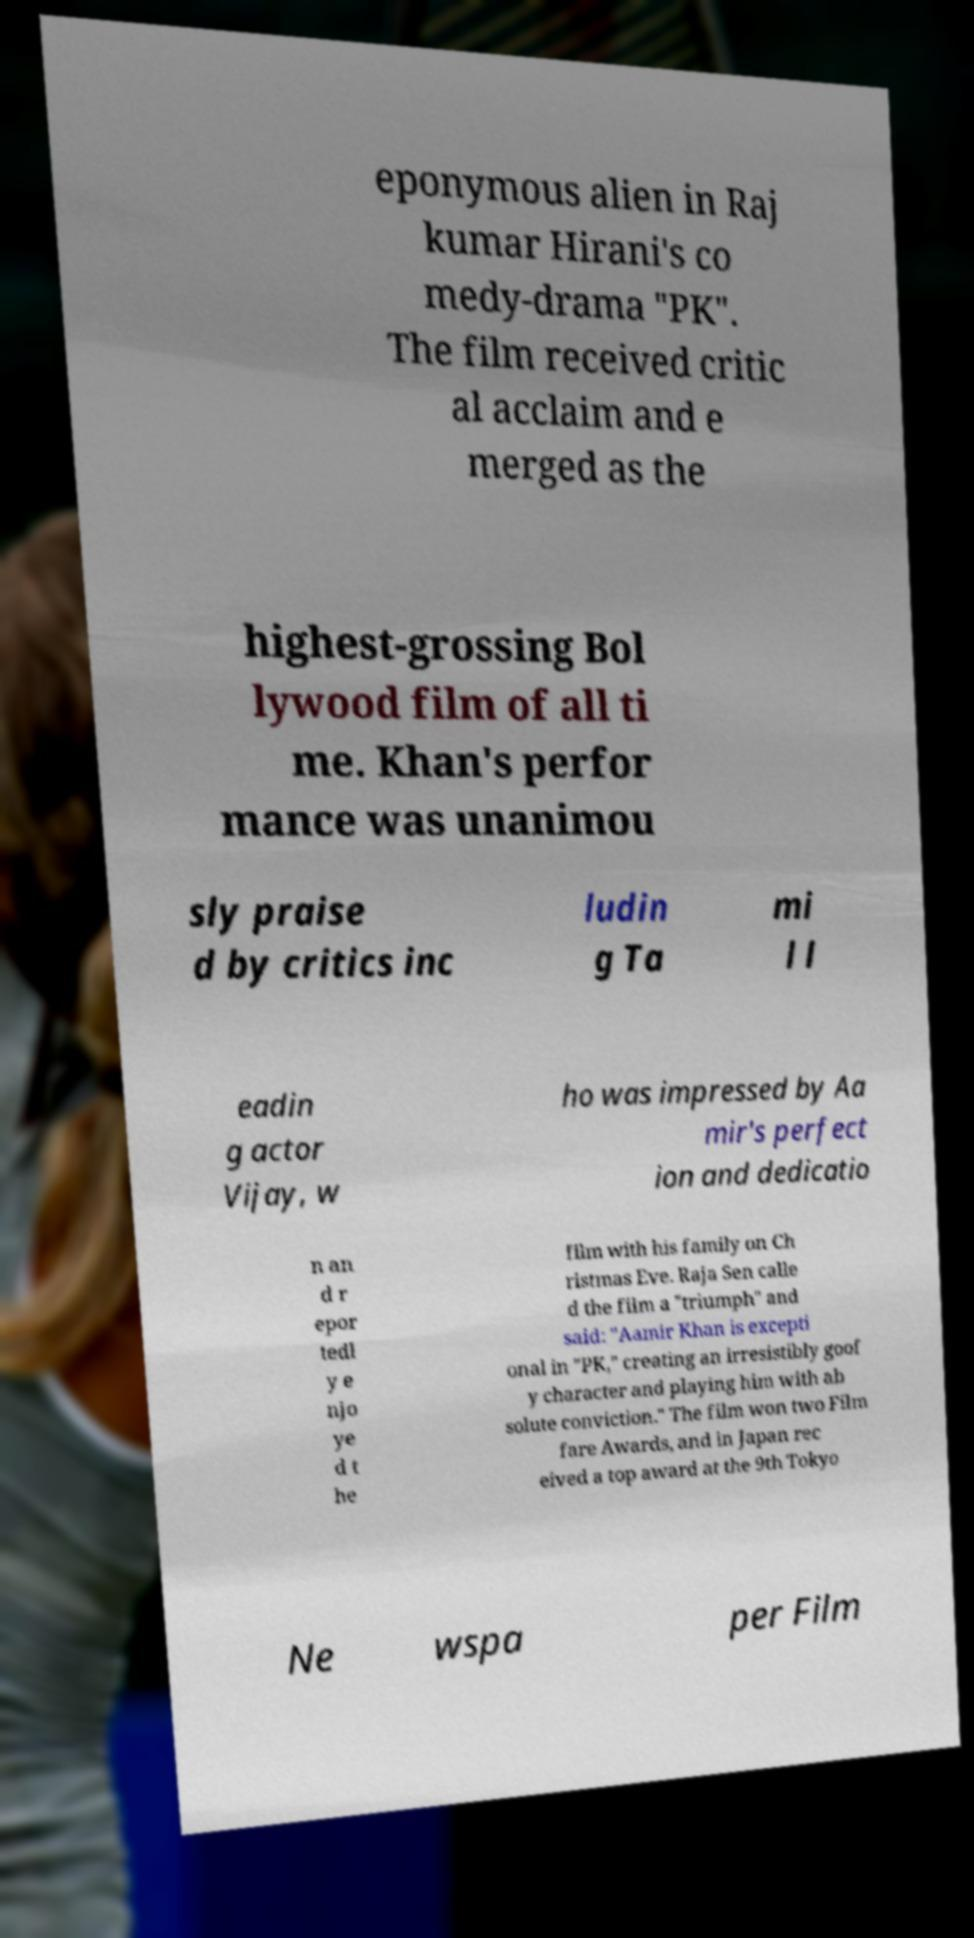Could you assist in decoding the text presented in this image and type it out clearly? eponymous alien in Raj kumar Hirani's co medy-drama "PK". The film received critic al acclaim and e merged as the highest-grossing Bol lywood film of all ti me. Khan's perfor mance was unanimou sly praise d by critics inc ludin g Ta mi l l eadin g actor Vijay, w ho was impressed by Aa mir's perfect ion and dedicatio n an d r epor tedl y e njo ye d t he film with his family on Ch ristmas Eve. Raja Sen calle d the film a "triumph" and said: "Aamir Khan is excepti onal in "PK," creating an irresistibly goof y character and playing him with ab solute conviction." The film won two Film fare Awards, and in Japan rec eived a top award at the 9th Tokyo Ne wspa per Film 